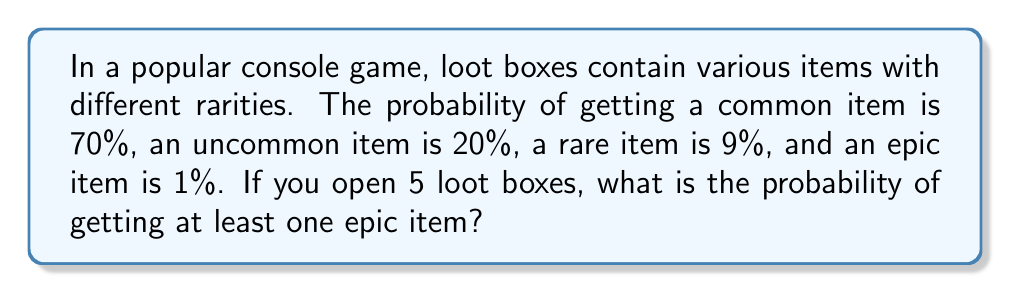What is the answer to this math problem? To solve this problem, we'll use the complement method:

1) First, let's calculate the probability of not getting an epic item in a single loot box:
   $P(\text{not epic}) = 1 - P(\text{epic}) = 1 - 0.01 = 0.99$

2) For 5 loot boxes, we need to calculate the probability of not getting an epic item in any of them:
   $P(\text{no epic in 5 boxes}) = (0.99)^5$

3) Now, the probability of getting at least one epic item is the complement of getting no epic items:
   $P(\text{at least one epic}) = 1 - P(\text{no epic in 5 boxes})$

4) Let's calculate:
   $$\begin{align*}
   P(\text{at least one epic}) &= 1 - (0.99)^5 \\
   &= 1 - 0.9509795918 \\
   &\approx 0.0490204082
   \end{align*}$$

5) Converting to a percentage:
   $0.0490204082 \times 100\% \approx 4.90\%$
Answer: The probability of getting at least one epic item when opening 5 loot boxes is approximately 4.90% or 0.0490. 